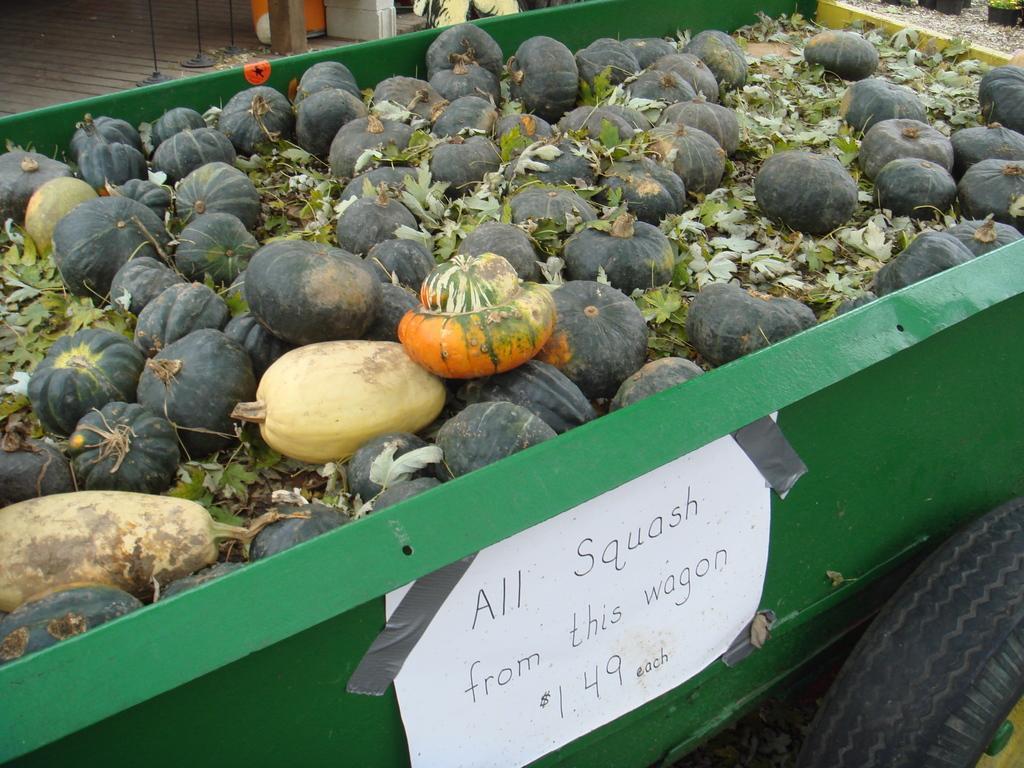How would you summarize this image in a sentence or two? In this image we can see there are few pumpkins are loaded in the truck and a label attached to it. 